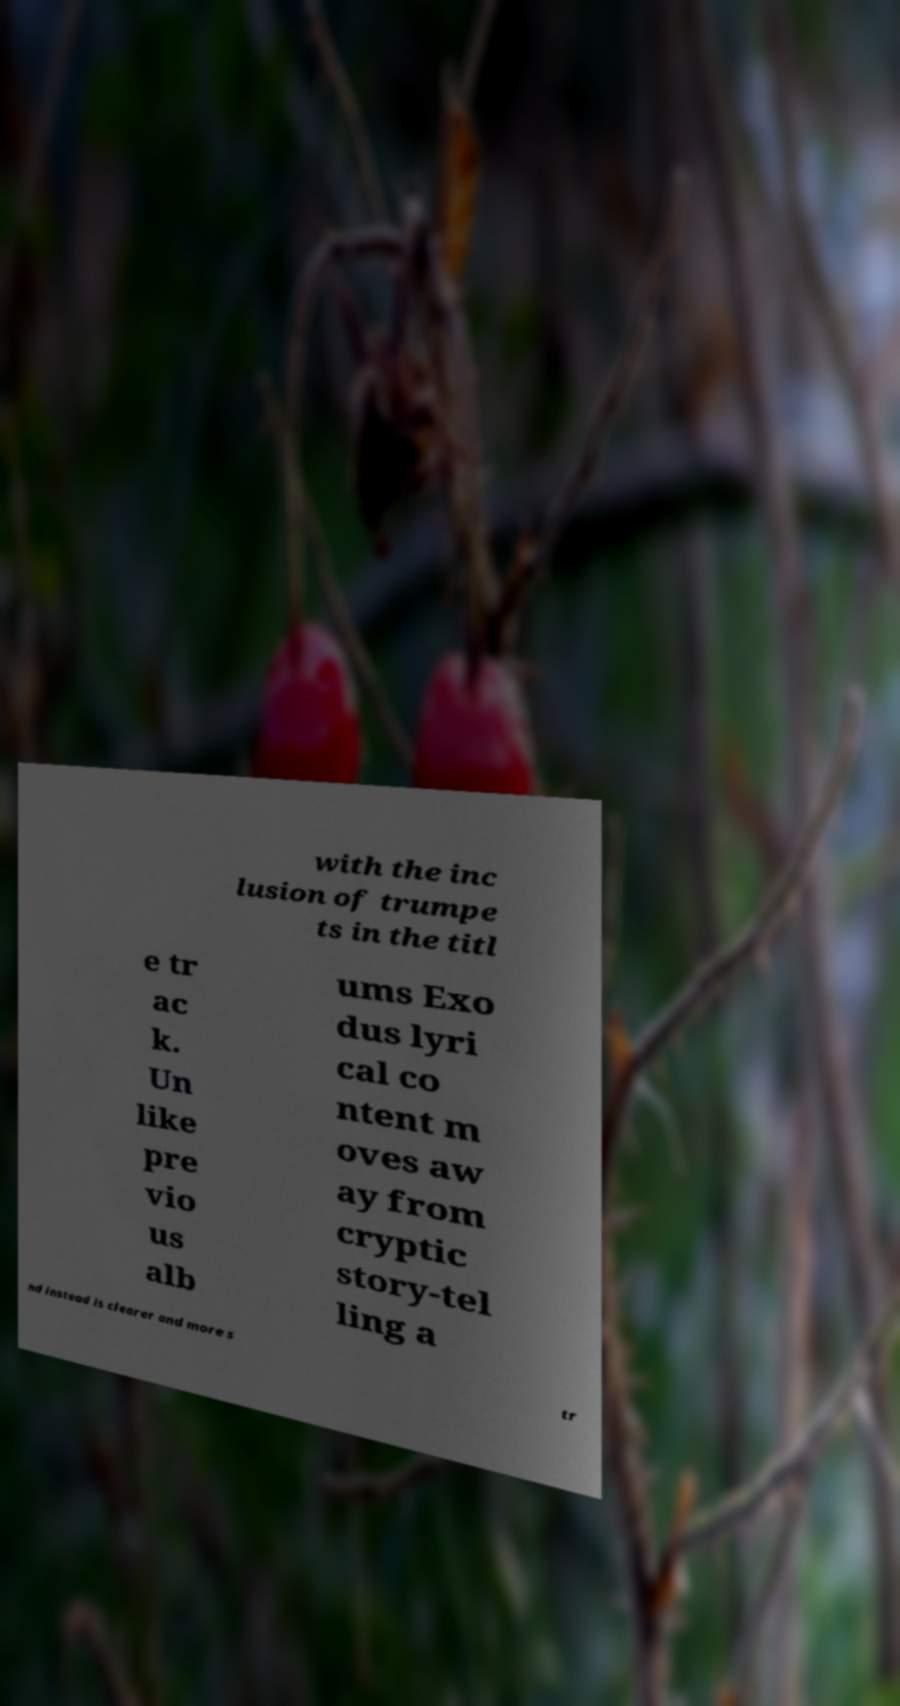Please identify and transcribe the text found in this image. with the inc lusion of trumpe ts in the titl e tr ac k. Un like pre vio us alb ums Exo dus lyri cal co ntent m oves aw ay from cryptic story-tel ling a nd instead is clearer and more s tr 